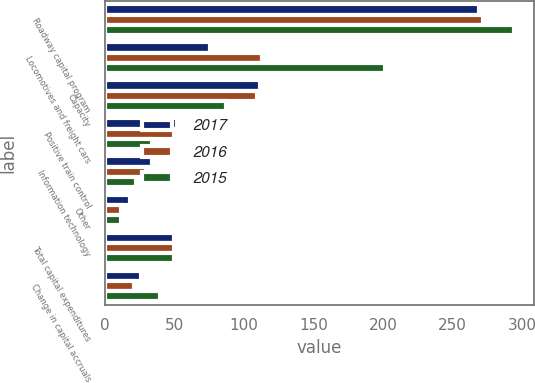<chart> <loc_0><loc_0><loc_500><loc_500><stacked_bar_chart><ecel><fcel>Roadway capital program<fcel>Locomotives and freight cars<fcel>Capacity<fcel>Positive train control<fcel>Information technology<fcel>Other<fcel>Total capital expenditures<fcel>Change in capital accruals<nl><fcel>2017<fcel>269.3<fcel>75.7<fcel>111.4<fcel>51.7<fcel>33.7<fcel>17.7<fcel>49.6<fcel>25.9<nl><fcel>2016<fcel>271.8<fcel>112.6<fcel>109.6<fcel>49.6<fcel>29.3<fcel>11.1<fcel>49.6<fcel>20.4<nl><fcel>2015<fcel>294<fcel>201.2<fcel>86.6<fcel>34<fcel>21.9<fcel>11<fcel>49.6<fcel>39.3<nl></chart> 